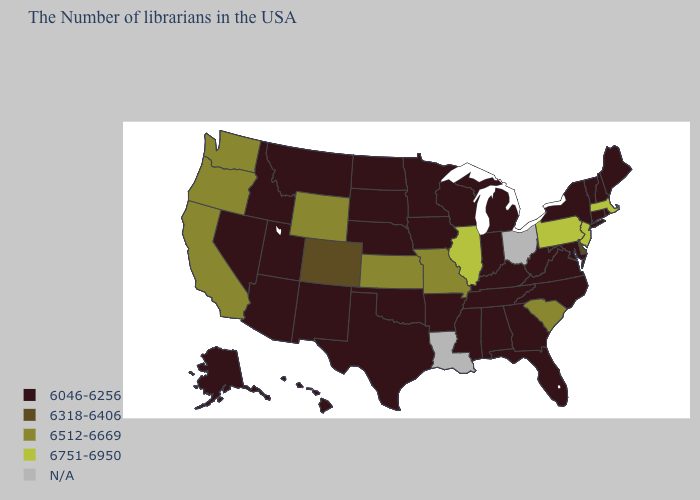What is the value of Kentucky?
Give a very brief answer. 6046-6256. Among the states that border Pennsylvania , does New Jersey have the highest value?
Short answer required. Yes. Which states have the lowest value in the USA?
Give a very brief answer. Maine, Rhode Island, New Hampshire, Vermont, Connecticut, New York, Maryland, Virginia, North Carolina, West Virginia, Florida, Georgia, Michigan, Kentucky, Indiana, Alabama, Tennessee, Wisconsin, Mississippi, Arkansas, Minnesota, Iowa, Nebraska, Oklahoma, Texas, South Dakota, North Dakota, New Mexico, Utah, Montana, Arizona, Idaho, Nevada, Alaska, Hawaii. How many symbols are there in the legend?
Be succinct. 5. Name the states that have a value in the range 6512-6669?
Quick response, please. South Carolina, Missouri, Kansas, Wyoming, California, Washington, Oregon. What is the value of Kentucky?
Concise answer only. 6046-6256. What is the value of Louisiana?
Short answer required. N/A. What is the value of Arizona?
Be succinct. 6046-6256. What is the value of Kentucky?
Write a very short answer. 6046-6256. Which states have the lowest value in the Northeast?
Be succinct. Maine, Rhode Island, New Hampshire, Vermont, Connecticut, New York. What is the value of Vermont?
Answer briefly. 6046-6256. What is the lowest value in the USA?
Give a very brief answer. 6046-6256. Among the states that border Missouri , does Nebraska have the highest value?
Quick response, please. No. 